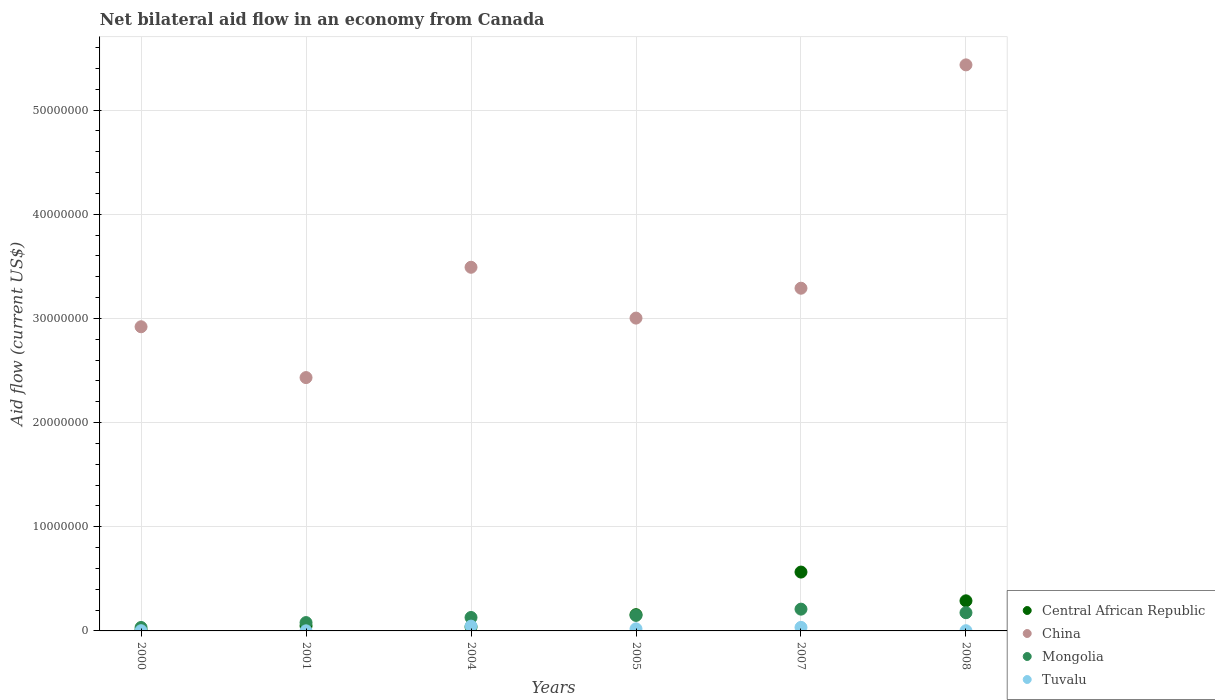Is the number of dotlines equal to the number of legend labels?
Your answer should be compact. Yes. What is the net bilateral aid flow in China in 2008?
Provide a short and direct response. 5.43e+07. Across all years, what is the minimum net bilateral aid flow in Tuvalu?
Ensure brevity in your answer.  10000. In which year was the net bilateral aid flow in Tuvalu minimum?
Keep it short and to the point. 2001. What is the total net bilateral aid flow in Mongolia in the graph?
Your answer should be very brief. 7.75e+06. What is the difference between the net bilateral aid flow in Central African Republic in 2004 and that in 2007?
Your answer should be very brief. -5.26e+06. What is the difference between the net bilateral aid flow in Tuvalu in 2004 and the net bilateral aid flow in Central African Republic in 2005?
Your response must be concise. -1.10e+06. What is the average net bilateral aid flow in Central African Republic per year?
Give a very brief answer. 1.84e+06. In the year 2001, what is the difference between the net bilateral aid flow in Tuvalu and net bilateral aid flow in Central African Republic?
Provide a short and direct response. -4.70e+05. What is the ratio of the net bilateral aid flow in Central African Republic in 2001 to that in 2008?
Offer a terse response. 0.17. Is the difference between the net bilateral aid flow in Tuvalu in 2004 and 2005 greater than the difference between the net bilateral aid flow in Central African Republic in 2004 and 2005?
Offer a terse response. Yes. What is the difference between the highest and the second highest net bilateral aid flow in Mongolia?
Offer a terse response. 3.40e+05. Is it the case that in every year, the sum of the net bilateral aid flow in Mongolia and net bilateral aid flow in Tuvalu  is greater than the sum of net bilateral aid flow in Central African Republic and net bilateral aid flow in China?
Make the answer very short. No. Does the net bilateral aid flow in Tuvalu monotonically increase over the years?
Ensure brevity in your answer.  No. Is the net bilateral aid flow in Tuvalu strictly less than the net bilateral aid flow in China over the years?
Your answer should be compact. Yes. How many dotlines are there?
Offer a very short reply. 4. How many years are there in the graph?
Your answer should be compact. 6. What is the difference between two consecutive major ticks on the Y-axis?
Provide a succinct answer. 1.00e+07. Does the graph contain any zero values?
Offer a terse response. No. Does the graph contain grids?
Ensure brevity in your answer.  Yes. How are the legend labels stacked?
Provide a short and direct response. Vertical. What is the title of the graph?
Offer a very short reply. Net bilateral aid flow in an economy from Canada. Does "Azerbaijan" appear as one of the legend labels in the graph?
Your response must be concise. No. What is the label or title of the X-axis?
Give a very brief answer. Years. What is the label or title of the Y-axis?
Ensure brevity in your answer.  Aid flow (current US$). What is the Aid flow (current US$) in China in 2000?
Your answer should be compact. 2.92e+07. What is the Aid flow (current US$) in Central African Republic in 2001?
Make the answer very short. 4.80e+05. What is the Aid flow (current US$) of China in 2001?
Offer a terse response. 2.43e+07. What is the Aid flow (current US$) of China in 2004?
Your answer should be compact. 3.49e+07. What is the Aid flow (current US$) in Mongolia in 2004?
Provide a succinct answer. 1.29e+06. What is the Aid flow (current US$) in Tuvalu in 2004?
Your answer should be compact. 4.60e+05. What is the Aid flow (current US$) of Central African Republic in 2005?
Your response must be concise. 1.56e+06. What is the Aid flow (current US$) of China in 2005?
Offer a very short reply. 3.00e+07. What is the Aid flow (current US$) in Mongolia in 2005?
Keep it short and to the point. 1.49e+06. What is the Aid flow (current US$) in Central African Republic in 2007?
Provide a succinct answer. 5.65e+06. What is the Aid flow (current US$) in China in 2007?
Provide a short and direct response. 3.29e+07. What is the Aid flow (current US$) in Mongolia in 2007?
Keep it short and to the point. 2.09e+06. What is the Aid flow (current US$) of Tuvalu in 2007?
Your answer should be very brief. 3.40e+05. What is the Aid flow (current US$) of Central African Republic in 2008?
Keep it short and to the point. 2.89e+06. What is the Aid flow (current US$) in China in 2008?
Make the answer very short. 5.43e+07. What is the Aid flow (current US$) of Mongolia in 2008?
Give a very brief answer. 1.75e+06. Across all years, what is the maximum Aid flow (current US$) of Central African Republic?
Your response must be concise. 5.65e+06. Across all years, what is the maximum Aid flow (current US$) in China?
Your response must be concise. 5.43e+07. Across all years, what is the maximum Aid flow (current US$) of Mongolia?
Your answer should be compact. 2.09e+06. Across all years, what is the minimum Aid flow (current US$) of Central African Republic?
Provide a succinct answer. 9.00e+04. Across all years, what is the minimum Aid flow (current US$) of China?
Make the answer very short. 2.43e+07. Across all years, what is the minimum Aid flow (current US$) in Mongolia?
Keep it short and to the point. 3.30e+05. What is the total Aid flow (current US$) of Central African Republic in the graph?
Keep it short and to the point. 1.11e+07. What is the total Aid flow (current US$) of China in the graph?
Provide a short and direct response. 2.06e+08. What is the total Aid flow (current US$) in Mongolia in the graph?
Your answer should be very brief. 7.75e+06. What is the total Aid flow (current US$) of Tuvalu in the graph?
Offer a terse response. 1.05e+06. What is the difference between the Aid flow (current US$) in Central African Republic in 2000 and that in 2001?
Make the answer very short. -3.90e+05. What is the difference between the Aid flow (current US$) of China in 2000 and that in 2001?
Your response must be concise. 4.88e+06. What is the difference between the Aid flow (current US$) of Mongolia in 2000 and that in 2001?
Your answer should be compact. -4.70e+05. What is the difference between the Aid flow (current US$) of Tuvalu in 2000 and that in 2001?
Your answer should be compact. 10000. What is the difference between the Aid flow (current US$) of China in 2000 and that in 2004?
Keep it short and to the point. -5.71e+06. What is the difference between the Aid flow (current US$) of Mongolia in 2000 and that in 2004?
Provide a short and direct response. -9.60e+05. What is the difference between the Aid flow (current US$) of Tuvalu in 2000 and that in 2004?
Your answer should be very brief. -4.40e+05. What is the difference between the Aid flow (current US$) in Central African Republic in 2000 and that in 2005?
Ensure brevity in your answer.  -1.47e+06. What is the difference between the Aid flow (current US$) in China in 2000 and that in 2005?
Your answer should be very brief. -8.30e+05. What is the difference between the Aid flow (current US$) of Mongolia in 2000 and that in 2005?
Your answer should be compact. -1.16e+06. What is the difference between the Aid flow (current US$) in Tuvalu in 2000 and that in 2005?
Your answer should be compact. -1.80e+05. What is the difference between the Aid flow (current US$) of Central African Republic in 2000 and that in 2007?
Your answer should be very brief. -5.56e+06. What is the difference between the Aid flow (current US$) in China in 2000 and that in 2007?
Make the answer very short. -3.70e+06. What is the difference between the Aid flow (current US$) of Mongolia in 2000 and that in 2007?
Your answer should be very brief. -1.76e+06. What is the difference between the Aid flow (current US$) in Tuvalu in 2000 and that in 2007?
Your answer should be compact. -3.20e+05. What is the difference between the Aid flow (current US$) in Central African Republic in 2000 and that in 2008?
Your response must be concise. -2.80e+06. What is the difference between the Aid flow (current US$) of China in 2000 and that in 2008?
Provide a succinct answer. -2.51e+07. What is the difference between the Aid flow (current US$) in Mongolia in 2000 and that in 2008?
Your answer should be compact. -1.42e+06. What is the difference between the Aid flow (current US$) in China in 2001 and that in 2004?
Ensure brevity in your answer.  -1.06e+07. What is the difference between the Aid flow (current US$) of Mongolia in 2001 and that in 2004?
Offer a terse response. -4.90e+05. What is the difference between the Aid flow (current US$) in Tuvalu in 2001 and that in 2004?
Your answer should be compact. -4.50e+05. What is the difference between the Aid flow (current US$) in Central African Republic in 2001 and that in 2005?
Your response must be concise. -1.08e+06. What is the difference between the Aid flow (current US$) in China in 2001 and that in 2005?
Provide a succinct answer. -5.71e+06. What is the difference between the Aid flow (current US$) in Mongolia in 2001 and that in 2005?
Provide a succinct answer. -6.90e+05. What is the difference between the Aid flow (current US$) of Central African Republic in 2001 and that in 2007?
Give a very brief answer. -5.17e+06. What is the difference between the Aid flow (current US$) of China in 2001 and that in 2007?
Offer a terse response. -8.58e+06. What is the difference between the Aid flow (current US$) in Mongolia in 2001 and that in 2007?
Offer a terse response. -1.29e+06. What is the difference between the Aid flow (current US$) of Tuvalu in 2001 and that in 2007?
Provide a succinct answer. -3.30e+05. What is the difference between the Aid flow (current US$) of Central African Republic in 2001 and that in 2008?
Make the answer very short. -2.41e+06. What is the difference between the Aid flow (current US$) of China in 2001 and that in 2008?
Your response must be concise. -3.00e+07. What is the difference between the Aid flow (current US$) in Mongolia in 2001 and that in 2008?
Provide a succinct answer. -9.50e+05. What is the difference between the Aid flow (current US$) in Tuvalu in 2001 and that in 2008?
Provide a short and direct response. -10000. What is the difference between the Aid flow (current US$) in Central African Republic in 2004 and that in 2005?
Provide a short and direct response. -1.17e+06. What is the difference between the Aid flow (current US$) in China in 2004 and that in 2005?
Your answer should be compact. 4.88e+06. What is the difference between the Aid flow (current US$) in Central African Republic in 2004 and that in 2007?
Your answer should be compact. -5.26e+06. What is the difference between the Aid flow (current US$) of China in 2004 and that in 2007?
Provide a succinct answer. 2.01e+06. What is the difference between the Aid flow (current US$) in Mongolia in 2004 and that in 2007?
Provide a short and direct response. -8.00e+05. What is the difference between the Aid flow (current US$) in Tuvalu in 2004 and that in 2007?
Provide a short and direct response. 1.20e+05. What is the difference between the Aid flow (current US$) in Central African Republic in 2004 and that in 2008?
Your response must be concise. -2.50e+06. What is the difference between the Aid flow (current US$) in China in 2004 and that in 2008?
Your answer should be very brief. -1.94e+07. What is the difference between the Aid flow (current US$) in Mongolia in 2004 and that in 2008?
Make the answer very short. -4.60e+05. What is the difference between the Aid flow (current US$) of Central African Republic in 2005 and that in 2007?
Make the answer very short. -4.09e+06. What is the difference between the Aid flow (current US$) in China in 2005 and that in 2007?
Provide a succinct answer. -2.87e+06. What is the difference between the Aid flow (current US$) of Mongolia in 2005 and that in 2007?
Provide a succinct answer. -6.00e+05. What is the difference between the Aid flow (current US$) of Tuvalu in 2005 and that in 2007?
Offer a terse response. -1.40e+05. What is the difference between the Aid flow (current US$) in Central African Republic in 2005 and that in 2008?
Your response must be concise. -1.33e+06. What is the difference between the Aid flow (current US$) in China in 2005 and that in 2008?
Offer a terse response. -2.43e+07. What is the difference between the Aid flow (current US$) of Central African Republic in 2007 and that in 2008?
Keep it short and to the point. 2.76e+06. What is the difference between the Aid flow (current US$) in China in 2007 and that in 2008?
Give a very brief answer. -2.14e+07. What is the difference between the Aid flow (current US$) in Tuvalu in 2007 and that in 2008?
Keep it short and to the point. 3.20e+05. What is the difference between the Aid flow (current US$) in Central African Republic in 2000 and the Aid flow (current US$) in China in 2001?
Keep it short and to the point. -2.42e+07. What is the difference between the Aid flow (current US$) of Central African Republic in 2000 and the Aid flow (current US$) of Mongolia in 2001?
Ensure brevity in your answer.  -7.10e+05. What is the difference between the Aid flow (current US$) in Central African Republic in 2000 and the Aid flow (current US$) in Tuvalu in 2001?
Make the answer very short. 8.00e+04. What is the difference between the Aid flow (current US$) of China in 2000 and the Aid flow (current US$) of Mongolia in 2001?
Your answer should be very brief. 2.84e+07. What is the difference between the Aid flow (current US$) of China in 2000 and the Aid flow (current US$) of Tuvalu in 2001?
Offer a terse response. 2.92e+07. What is the difference between the Aid flow (current US$) in Mongolia in 2000 and the Aid flow (current US$) in Tuvalu in 2001?
Provide a short and direct response. 3.20e+05. What is the difference between the Aid flow (current US$) in Central African Republic in 2000 and the Aid flow (current US$) in China in 2004?
Give a very brief answer. -3.48e+07. What is the difference between the Aid flow (current US$) of Central African Republic in 2000 and the Aid flow (current US$) of Mongolia in 2004?
Offer a very short reply. -1.20e+06. What is the difference between the Aid flow (current US$) of Central African Republic in 2000 and the Aid flow (current US$) of Tuvalu in 2004?
Give a very brief answer. -3.70e+05. What is the difference between the Aid flow (current US$) of China in 2000 and the Aid flow (current US$) of Mongolia in 2004?
Make the answer very short. 2.79e+07. What is the difference between the Aid flow (current US$) in China in 2000 and the Aid flow (current US$) in Tuvalu in 2004?
Keep it short and to the point. 2.87e+07. What is the difference between the Aid flow (current US$) of Central African Republic in 2000 and the Aid flow (current US$) of China in 2005?
Ensure brevity in your answer.  -2.99e+07. What is the difference between the Aid flow (current US$) in Central African Republic in 2000 and the Aid flow (current US$) in Mongolia in 2005?
Keep it short and to the point. -1.40e+06. What is the difference between the Aid flow (current US$) in Central African Republic in 2000 and the Aid flow (current US$) in Tuvalu in 2005?
Ensure brevity in your answer.  -1.10e+05. What is the difference between the Aid flow (current US$) in China in 2000 and the Aid flow (current US$) in Mongolia in 2005?
Ensure brevity in your answer.  2.77e+07. What is the difference between the Aid flow (current US$) in China in 2000 and the Aid flow (current US$) in Tuvalu in 2005?
Your response must be concise. 2.90e+07. What is the difference between the Aid flow (current US$) of Mongolia in 2000 and the Aid flow (current US$) of Tuvalu in 2005?
Your answer should be compact. 1.30e+05. What is the difference between the Aid flow (current US$) of Central African Republic in 2000 and the Aid flow (current US$) of China in 2007?
Make the answer very short. -3.28e+07. What is the difference between the Aid flow (current US$) in Central African Republic in 2000 and the Aid flow (current US$) in Tuvalu in 2007?
Keep it short and to the point. -2.50e+05. What is the difference between the Aid flow (current US$) of China in 2000 and the Aid flow (current US$) of Mongolia in 2007?
Provide a short and direct response. 2.71e+07. What is the difference between the Aid flow (current US$) of China in 2000 and the Aid flow (current US$) of Tuvalu in 2007?
Offer a very short reply. 2.89e+07. What is the difference between the Aid flow (current US$) of Mongolia in 2000 and the Aid flow (current US$) of Tuvalu in 2007?
Offer a terse response. -10000. What is the difference between the Aid flow (current US$) in Central African Republic in 2000 and the Aid flow (current US$) in China in 2008?
Your answer should be compact. -5.42e+07. What is the difference between the Aid flow (current US$) in Central African Republic in 2000 and the Aid flow (current US$) in Mongolia in 2008?
Provide a short and direct response. -1.66e+06. What is the difference between the Aid flow (current US$) of Central African Republic in 2000 and the Aid flow (current US$) of Tuvalu in 2008?
Your answer should be compact. 7.00e+04. What is the difference between the Aid flow (current US$) in China in 2000 and the Aid flow (current US$) in Mongolia in 2008?
Your answer should be compact. 2.74e+07. What is the difference between the Aid flow (current US$) of China in 2000 and the Aid flow (current US$) of Tuvalu in 2008?
Your answer should be very brief. 2.92e+07. What is the difference between the Aid flow (current US$) in Central African Republic in 2001 and the Aid flow (current US$) in China in 2004?
Provide a succinct answer. -3.44e+07. What is the difference between the Aid flow (current US$) in Central African Republic in 2001 and the Aid flow (current US$) in Mongolia in 2004?
Keep it short and to the point. -8.10e+05. What is the difference between the Aid flow (current US$) in China in 2001 and the Aid flow (current US$) in Mongolia in 2004?
Give a very brief answer. 2.30e+07. What is the difference between the Aid flow (current US$) in China in 2001 and the Aid flow (current US$) in Tuvalu in 2004?
Your answer should be very brief. 2.39e+07. What is the difference between the Aid flow (current US$) of Central African Republic in 2001 and the Aid flow (current US$) of China in 2005?
Provide a succinct answer. -2.96e+07. What is the difference between the Aid flow (current US$) of Central African Republic in 2001 and the Aid flow (current US$) of Mongolia in 2005?
Provide a short and direct response. -1.01e+06. What is the difference between the Aid flow (current US$) of Central African Republic in 2001 and the Aid flow (current US$) of Tuvalu in 2005?
Give a very brief answer. 2.80e+05. What is the difference between the Aid flow (current US$) in China in 2001 and the Aid flow (current US$) in Mongolia in 2005?
Your answer should be very brief. 2.28e+07. What is the difference between the Aid flow (current US$) in China in 2001 and the Aid flow (current US$) in Tuvalu in 2005?
Offer a very short reply. 2.41e+07. What is the difference between the Aid flow (current US$) of Central African Republic in 2001 and the Aid flow (current US$) of China in 2007?
Provide a succinct answer. -3.24e+07. What is the difference between the Aid flow (current US$) of Central African Republic in 2001 and the Aid flow (current US$) of Mongolia in 2007?
Make the answer very short. -1.61e+06. What is the difference between the Aid flow (current US$) in China in 2001 and the Aid flow (current US$) in Mongolia in 2007?
Provide a short and direct response. 2.22e+07. What is the difference between the Aid flow (current US$) of China in 2001 and the Aid flow (current US$) of Tuvalu in 2007?
Keep it short and to the point. 2.40e+07. What is the difference between the Aid flow (current US$) in Mongolia in 2001 and the Aid flow (current US$) in Tuvalu in 2007?
Your response must be concise. 4.60e+05. What is the difference between the Aid flow (current US$) in Central African Republic in 2001 and the Aid flow (current US$) in China in 2008?
Provide a succinct answer. -5.39e+07. What is the difference between the Aid flow (current US$) in Central African Republic in 2001 and the Aid flow (current US$) in Mongolia in 2008?
Ensure brevity in your answer.  -1.27e+06. What is the difference between the Aid flow (current US$) in Central African Republic in 2001 and the Aid flow (current US$) in Tuvalu in 2008?
Your answer should be compact. 4.60e+05. What is the difference between the Aid flow (current US$) of China in 2001 and the Aid flow (current US$) of Mongolia in 2008?
Your answer should be compact. 2.26e+07. What is the difference between the Aid flow (current US$) of China in 2001 and the Aid flow (current US$) of Tuvalu in 2008?
Give a very brief answer. 2.43e+07. What is the difference between the Aid flow (current US$) in Mongolia in 2001 and the Aid flow (current US$) in Tuvalu in 2008?
Offer a very short reply. 7.80e+05. What is the difference between the Aid flow (current US$) of Central African Republic in 2004 and the Aid flow (current US$) of China in 2005?
Your answer should be very brief. -2.96e+07. What is the difference between the Aid flow (current US$) of Central African Republic in 2004 and the Aid flow (current US$) of Mongolia in 2005?
Your response must be concise. -1.10e+06. What is the difference between the Aid flow (current US$) in China in 2004 and the Aid flow (current US$) in Mongolia in 2005?
Provide a short and direct response. 3.34e+07. What is the difference between the Aid flow (current US$) in China in 2004 and the Aid flow (current US$) in Tuvalu in 2005?
Your answer should be compact. 3.47e+07. What is the difference between the Aid flow (current US$) of Mongolia in 2004 and the Aid flow (current US$) of Tuvalu in 2005?
Your response must be concise. 1.09e+06. What is the difference between the Aid flow (current US$) in Central African Republic in 2004 and the Aid flow (current US$) in China in 2007?
Offer a very short reply. -3.25e+07. What is the difference between the Aid flow (current US$) in Central African Republic in 2004 and the Aid flow (current US$) in Mongolia in 2007?
Your response must be concise. -1.70e+06. What is the difference between the Aid flow (current US$) of Central African Republic in 2004 and the Aid flow (current US$) of Tuvalu in 2007?
Keep it short and to the point. 5.00e+04. What is the difference between the Aid flow (current US$) in China in 2004 and the Aid flow (current US$) in Mongolia in 2007?
Ensure brevity in your answer.  3.28e+07. What is the difference between the Aid flow (current US$) in China in 2004 and the Aid flow (current US$) in Tuvalu in 2007?
Make the answer very short. 3.46e+07. What is the difference between the Aid flow (current US$) of Mongolia in 2004 and the Aid flow (current US$) of Tuvalu in 2007?
Your answer should be very brief. 9.50e+05. What is the difference between the Aid flow (current US$) in Central African Republic in 2004 and the Aid flow (current US$) in China in 2008?
Your response must be concise. -5.40e+07. What is the difference between the Aid flow (current US$) of Central African Republic in 2004 and the Aid flow (current US$) of Mongolia in 2008?
Make the answer very short. -1.36e+06. What is the difference between the Aid flow (current US$) in Central African Republic in 2004 and the Aid flow (current US$) in Tuvalu in 2008?
Provide a succinct answer. 3.70e+05. What is the difference between the Aid flow (current US$) of China in 2004 and the Aid flow (current US$) of Mongolia in 2008?
Keep it short and to the point. 3.32e+07. What is the difference between the Aid flow (current US$) in China in 2004 and the Aid flow (current US$) in Tuvalu in 2008?
Your answer should be compact. 3.49e+07. What is the difference between the Aid flow (current US$) in Mongolia in 2004 and the Aid flow (current US$) in Tuvalu in 2008?
Your answer should be very brief. 1.27e+06. What is the difference between the Aid flow (current US$) in Central African Republic in 2005 and the Aid flow (current US$) in China in 2007?
Your response must be concise. -3.13e+07. What is the difference between the Aid flow (current US$) in Central African Republic in 2005 and the Aid flow (current US$) in Mongolia in 2007?
Provide a succinct answer. -5.30e+05. What is the difference between the Aid flow (current US$) in Central African Republic in 2005 and the Aid flow (current US$) in Tuvalu in 2007?
Provide a succinct answer. 1.22e+06. What is the difference between the Aid flow (current US$) in China in 2005 and the Aid flow (current US$) in Mongolia in 2007?
Give a very brief answer. 2.79e+07. What is the difference between the Aid flow (current US$) of China in 2005 and the Aid flow (current US$) of Tuvalu in 2007?
Your answer should be compact. 2.97e+07. What is the difference between the Aid flow (current US$) of Mongolia in 2005 and the Aid flow (current US$) of Tuvalu in 2007?
Your answer should be very brief. 1.15e+06. What is the difference between the Aid flow (current US$) of Central African Republic in 2005 and the Aid flow (current US$) of China in 2008?
Give a very brief answer. -5.28e+07. What is the difference between the Aid flow (current US$) in Central African Republic in 2005 and the Aid flow (current US$) in Tuvalu in 2008?
Offer a terse response. 1.54e+06. What is the difference between the Aid flow (current US$) of China in 2005 and the Aid flow (current US$) of Mongolia in 2008?
Offer a very short reply. 2.83e+07. What is the difference between the Aid flow (current US$) of China in 2005 and the Aid flow (current US$) of Tuvalu in 2008?
Offer a terse response. 3.00e+07. What is the difference between the Aid flow (current US$) of Mongolia in 2005 and the Aid flow (current US$) of Tuvalu in 2008?
Ensure brevity in your answer.  1.47e+06. What is the difference between the Aid flow (current US$) in Central African Republic in 2007 and the Aid flow (current US$) in China in 2008?
Your response must be concise. -4.87e+07. What is the difference between the Aid flow (current US$) of Central African Republic in 2007 and the Aid flow (current US$) of Mongolia in 2008?
Your response must be concise. 3.90e+06. What is the difference between the Aid flow (current US$) of Central African Republic in 2007 and the Aid flow (current US$) of Tuvalu in 2008?
Your answer should be compact. 5.63e+06. What is the difference between the Aid flow (current US$) of China in 2007 and the Aid flow (current US$) of Mongolia in 2008?
Your answer should be very brief. 3.12e+07. What is the difference between the Aid flow (current US$) of China in 2007 and the Aid flow (current US$) of Tuvalu in 2008?
Your answer should be very brief. 3.29e+07. What is the difference between the Aid flow (current US$) of Mongolia in 2007 and the Aid flow (current US$) of Tuvalu in 2008?
Keep it short and to the point. 2.07e+06. What is the average Aid flow (current US$) in Central African Republic per year?
Your answer should be compact. 1.84e+06. What is the average Aid flow (current US$) of China per year?
Offer a very short reply. 3.43e+07. What is the average Aid flow (current US$) of Mongolia per year?
Offer a very short reply. 1.29e+06. What is the average Aid flow (current US$) of Tuvalu per year?
Offer a terse response. 1.75e+05. In the year 2000, what is the difference between the Aid flow (current US$) of Central African Republic and Aid flow (current US$) of China?
Your response must be concise. -2.91e+07. In the year 2000, what is the difference between the Aid flow (current US$) of Central African Republic and Aid flow (current US$) of Mongolia?
Give a very brief answer. -2.40e+05. In the year 2000, what is the difference between the Aid flow (current US$) in China and Aid flow (current US$) in Mongolia?
Your answer should be compact. 2.89e+07. In the year 2000, what is the difference between the Aid flow (current US$) of China and Aid flow (current US$) of Tuvalu?
Make the answer very short. 2.92e+07. In the year 2000, what is the difference between the Aid flow (current US$) in Mongolia and Aid flow (current US$) in Tuvalu?
Keep it short and to the point. 3.10e+05. In the year 2001, what is the difference between the Aid flow (current US$) in Central African Republic and Aid flow (current US$) in China?
Make the answer very short. -2.38e+07. In the year 2001, what is the difference between the Aid flow (current US$) of Central African Republic and Aid flow (current US$) of Mongolia?
Provide a short and direct response. -3.20e+05. In the year 2001, what is the difference between the Aid flow (current US$) of China and Aid flow (current US$) of Mongolia?
Give a very brief answer. 2.35e+07. In the year 2001, what is the difference between the Aid flow (current US$) of China and Aid flow (current US$) of Tuvalu?
Make the answer very short. 2.43e+07. In the year 2001, what is the difference between the Aid flow (current US$) in Mongolia and Aid flow (current US$) in Tuvalu?
Make the answer very short. 7.90e+05. In the year 2004, what is the difference between the Aid flow (current US$) of Central African Republic and Aid flow (current US$) of China?
Offer a terse response. -3.45e+07. In the year 2004, what is the difference between the Aid flow (current US$) in Central African Republic and Aid flow (current US$) in Mongolia?
Your answer should be very brief. -9.00e+05. In the year 2004, what is the difference between the Aid flow (current US$) of China and Aid flow (current US$) of Mongolia?
Provide a short and direct response. 3.36e+07. In the year 2004, what is the difference between the Aid flow (current US$) in China and Aid flow (current US$) in Tuvalu?
Offer a terse response. 3.44e+07. In the year 2004, what is the difference between the Aid flow (current US$) of Mongolia and Aid flow (current US$) of Tuvalu?
Your answer should be very brief. 8.30e+05. In the year 2005, what is the difference between the Aid flow (current US$) in Central African Republic and Aid flow (current US$) in China?
Offer a very short reply. -2.85e+07. In the year 2005, what is the difference between the Aid flow (current US$) in Central African Republic and Aid flow (current US$) in Tuvalu?
Your answer should be compact. 1.36e+06. In the year 2005, what is the difference between the Aid flow (current US$) of China and Aid flow (current US$) of Mongolia?
Make the answer very short. 2.85e+07. In the year 2005, what is the difference between the Aid flow (current US$) in China and Aid flow (current US$) in Tuvalu?
Provide a succinct answer. 2.98e+07. In the year 2005, what is the difference between the Aid flow (current US$) in Mongolia and Aid flow (current US$) in Tuvalu?
Keep it short and to the point. 1.29e+06. In the year 2007, what is the difference between the Aid flow (current US$) in Central African Republic and Aid flow (current US$) in China?
Provide a short and direct response. -2.72e+07. In the year 2007, what is the difference between the Aid flow (current US$) of Central African Republic and Aid flow (current US$) of Mongolia?
Provide a succinct answer. 3.56e+06. In the year 2007, what is the difference between the Aid flow (current US$) of Central African Republic and Aid flow (current US$) of Tuvalu?
Ensure brevity in your answer.  5.31e+06. In the year 2007, what is the difference between the Aid flow (current US$) of China and Aid flow (current US$) of Mongolia?
Offer a very short reply. 3.08e+07. In the year 2007, what is the difference between the Aid flow (current US$) in China and Aid flow (current US$) in Tuvalu?
Provide a succinct answer. 3.26e+07. In the year 2007, what is the difference between the Aid flow (current US$) of Mongolia and Aid flow (current US$) of Tuvalu?
Give a very brief answer. 1.75e+06. In the year 2008, what is the difference between the Aid flow (current US$) in Central African Republic and Aid flow (current US$) in China?
Your answer should be compact. -5.14e+07. In the year 2008, what is the difference between the Aid flow (current US$) of Central African Republic and Aid flow (current US$) of Mongolia?
Ensure brevity in your answer.  1.14e+06. In the year 2008, what is the difference between the Aid flow (current US$) of Central African Republic and Aid flow (current US$) of Tuvalu?
Make the answer very short. 2.87e+06. In the year 2008, what is the difference between the Aid flow (current US$) of China and Aid flow (current US$) of Mongolia?
Keep it short and to the point. 5.26e+07. In the year 2008, what is the difference between the Aid flow (current US$) of China and Aid flow (current US$) of Tuvalu?
Your answer should be very brief. 5.43e+07. In the year 2008, what is the difference between the Aid flow (current US$) of Mongolia and Aid flow (current US$) of Tuvalu?
Offer a very short reply. 1.73e+06. What is the ratio of the Aid flow (current US$) in Central African Republic in 2000 to that in 2001?
Make the answer very short. 0.19. What is the ratio of the Aid flow (current US$) of China in 2000 to that in 2001?
Your answer should be compact. 1.2. What is the ratio of the Aid flow (current US$) of Mongolia in 2000 to that in 2001?
Make the answer very short. 0.41. What is the ratio of the Aid flow (current US$) in Tuvalu in 2000 to that in 2001?
Offer a very short reply. 2. What is the ratio of the Aid flow (current US$) of Central African Republic in 2000 to that in 2004?
Offer a very short reply. 0.23. What is the ratio of the Aid flow (current US$) of China in 2000 to that in 2004?
Ensure brevity in your answer.  0.84. What is the ratio of the Aid flow (current US$) of Mongolia in 2000 to that in 2004?
Provide a succinct answer. 0.26. What is the ratio of the Aid flow (current US$) of Tuvalu in 2000 to that in 2004?
Provide a short and direct response. 0.04. What is the ratio of the Aid flow (current US$) in Central African Republic in 2000 to that in 2005?
Your response must be concise. 0.06. What is the ratio of the Aid flow (current US$) in China in 2000 to that in 2005?
Make the answer very short. 0.97. What is the ratio of the Aid flow (current US$) of Mongolia in 2000 to that in 2005?
Make the answer very short. 0.22. What is the ratio of the Aid flow (current US$) in Central African Republic in 2000 to that in 2007?
Give a very brief answer. 0.02. What is the ratio of the Aid flow (current US$) in China in 2000 to that in 2007?
Your answer should be very brief. 0.89. What is the ratio of the Aid flow (current US$) of Mongolia in 2000 to that in 2007?
Your response must be concise. 0.16. What is the ratio of the Aid flow (current US$) in Tuvalu in 2000 to that in 2007?
Make the answer very short. 0.06. What is the ratio of the Aid flow (current US$) of Central African Republic in 2000 to that in 2008?
Ensure brevity in your answer.  0.03. What is the ratio of the Aid flow (current US$) in China in 2000 to that in 2008?
Give a very brief answer. 0.54. What is the ratio of the Aid flow (current US$) of Mongolia in 2000 to that in 2008?
Your answer should be compact. 0.19. What is the ratio of the Aid flow (current US$) in Central African Republic in 2001 to that in 2004?
Provide a succinct answer. 1.23. What is the ratio of the Aid flow (current US$) of China in 2001 to that in 2004?
Provide a succinct answer. 0.7. What is the ratio of the Aid flow (current US$) in Mongolia in 2001 to that in 2004?
Keep it short and to the point. 0.62. What is the ratio of the Aid flow (current US$) in Tuvalu in 2001 to that in 2004?
Provide a succinct answer. 0.02. What is the ratio of the Aid flow (current US$) in Central African Republic in 2001 to that in 2005?
Ensure brevity in your answer.  0.31. What is the ratio of the Aid flow (current US$) in China in 2001 to that in 2005?
Your response must be concise. 0.81. What is the ratio of the Aid flow (current US$) in Mongolia in 2001 to that in 2005?
Your response must be concise. 0.54. What is the ratio of the Aid flow (current US$) in Central African Republic in 2001 to that in 2007?
Provide a short and direct response. 0.09. What is the ratio of the Aid flow (current US$) in China in 2001 to that in 2007?
Make the answer very short. 0.74. What is the ratio of the Aid flow (current US$) in Mongolia in 2001 to that in 2007?
Your answer should be compact. 0.38. What is the ratio of the Aid flow (current US$) of Tuvalu in 2001 to that in 2007?
Your response must be concise. 0.03. What is the ratio of the Aid flow (current US$) in Central African Republic in 2001 to that in 2008?
Provide a short and direct response. 0.17. What is the ratio of the Aid flow (current US$) of China in 2001 to that in 2008?
Offer a very short reply. 0.45. What is the ratio of the Aid flow (current US$) of Mongolia in 2001 to that in 2008?
Keep it short and to the point. 0.46. What is the ratio of the Aid flow (current US$) of Tuvalu in 2001 to that in 2008?
Offer a very short reply. 0.5. What is the ratio of the Aid flow (current US$) of Central African Republic in 2004 to that in 2005?
Make the answer very short. 0.25. What is the ratio of the Aid flow (current US$) of China in 2004 to that in 2005?
Make the answer very short. 1.16. What is the ratio of the Aid flow (current US$) in Mongolia in 2004 to that in 2005?
Your answer should be very brief. 0.87. What is the ratio of the Aid flow (current US$) of Central African Republic in 2004 to that in 2007?
Your answer should be compact. 0.07. What is the ratio of the Aid flow (current US$) of China in 2004 to that in 2007?
Make the answer very short. 1.06. What is the ratio of the Aid flow (current US$) of Mongolia in 2004 to that in 2007?
Provide a succinct answer. 0.62. What is the ratio of the Aid flow (current US$) of Tuvalu in 2004 to that in 2007?
Your response must be concise. 1.35. What is the ratio of the Aid flow (current US$) in Central African Republic in 2004 to that in 2008?
Make the answer very short. 0.13. What is the ratio of the Aid flow (current US$) in China in 2004 to that in 2008?
Provide a short and direct response. 0.64. What is the ratio of the Aid flow (current US$) of Mongolia in 2004 to that in 2008?
Offer a very short reply. 0.74. What is the ratio of the Aid flow (current US$) of Central African Republic in 2005 to that in 2007?
Your answer should be very brief. 0.28. What is the ratio of the Aid flow (current US$) of China in 2005 to that in 2007?
Ensure brevity in your answer.  0.91. What is the ratio of the Aid flow (current US$) in Mongolia in 2005 to that in 2007?
Your answer should be compact. 0.71. What is the ratio of the Aid flow (current US$) of Tuvalu in 2005 to that in 2007?
Provide a succinct answer. 0.59. What is the ratio of the Aid flow (current US$) in Central African Republic in 2005 to that in 2008?
Your response must be concise. 0.54. What is the ratio of the Aid flow (current US$) in China in 2005 to that in 2008?
Make the answer very short. 0.55. What is the ratio of the Aid flow (current US$) in Mongolia in 2005 to that in 2008?
Offer a very short reply. 0.85. What is the ratio of the Aid flow (current US$) in Tuvalu in 2005 to that in 2008?
Give a very brief answer. 10. What is the ratio of the Aid flow (current US$) in Central African Republic in 2007 to that in 2008?
Your answer should be very brief. 1.96. What is the ratio of the Aid flow (current US$) of China in 2007 to that in 2008?
Give a very brief answer. 0.61. What is the ratio of the Aid flow (current US$) of Mongolia in 2007 to that in 2008?
Give a very brief answer. 1.19. What is the ratio of the Aid flow (current US$) of Tuvalu in 2007 to that in 2008?
Keep it short and to the point. 17. What is the difference between the highest and the second highest Aid flow (current US$) in Central African Republic?
Provide a short and direct response. 2.76e+06. What is the difference between the highest and the second highest Aid flow (current US$) of China?
Offer a terse response. 1.94e+07. What is the difference between the highest and the second highest Aid flow (current US$) in Tuvalu?
Ensure brevity in your answer.  1.20e+05. What is the difference between the highest and the lowest Aid flow (current US$) of Central African Republic?
Your response must be concise. 5.56e+06. What is the difference between the highest and the lowest Aid flow (current US$) in China?
Your answer should be very brief. 3.00e+07. What is the difference between the highest and the lowest Aid flow (current US$) in Mongolia?
Provide a short and direct response. 1.76e+06. 